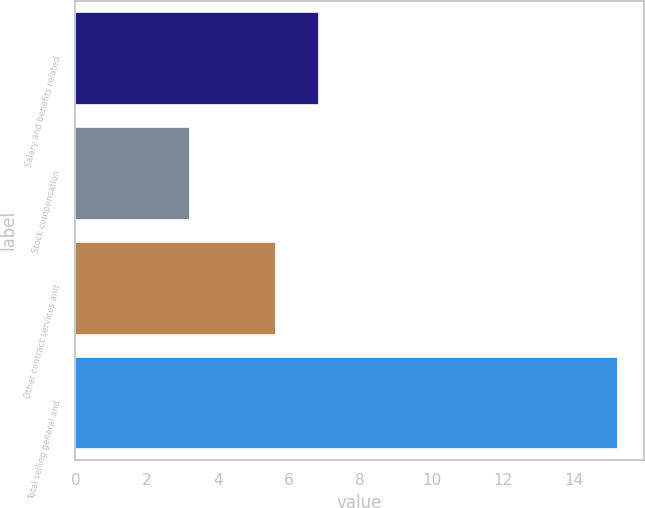Convert chart to OTSL. <chart><loc_0><loc_0><loc_500><loc_500><bar_chart><fcel>Salary and benefits related<fcel>Stock compensation<fcel>Other contract services and<fcel>Total selling general and<nl><fcel>6.8<fcel>3.2<fcel>5.6<fcel>15.2<nl></chart> 